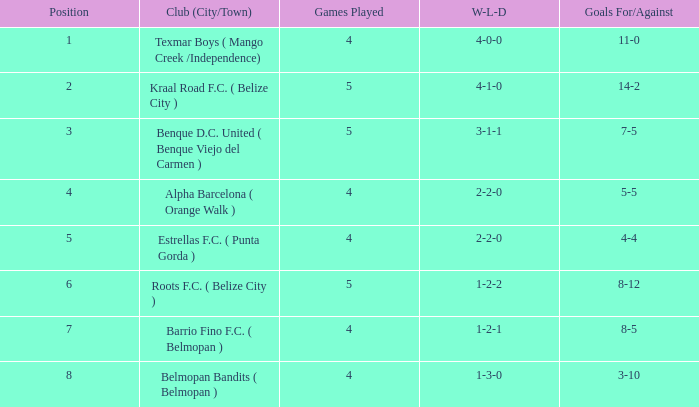What's the w-l-d with position being 1 4-0-0. 